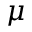Convert formula to latex. <formula><loc_0><loc_0><loc_500><loc_500>\mu</formula> 